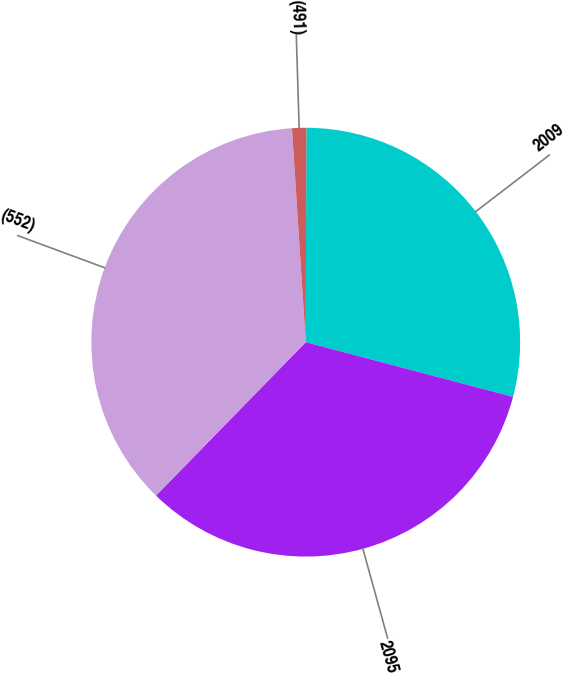Convert chart to OTSL. <chart><loc_0><loc_0><loc_500><loc_500><pie_chart><fcel>2009<fcel>2095<fcel>(552)<fcel>(491)<nl><fcel>29.06%<fcel>33.2%<fcel>36.67%<fcel>1.07%<nl></chart> 